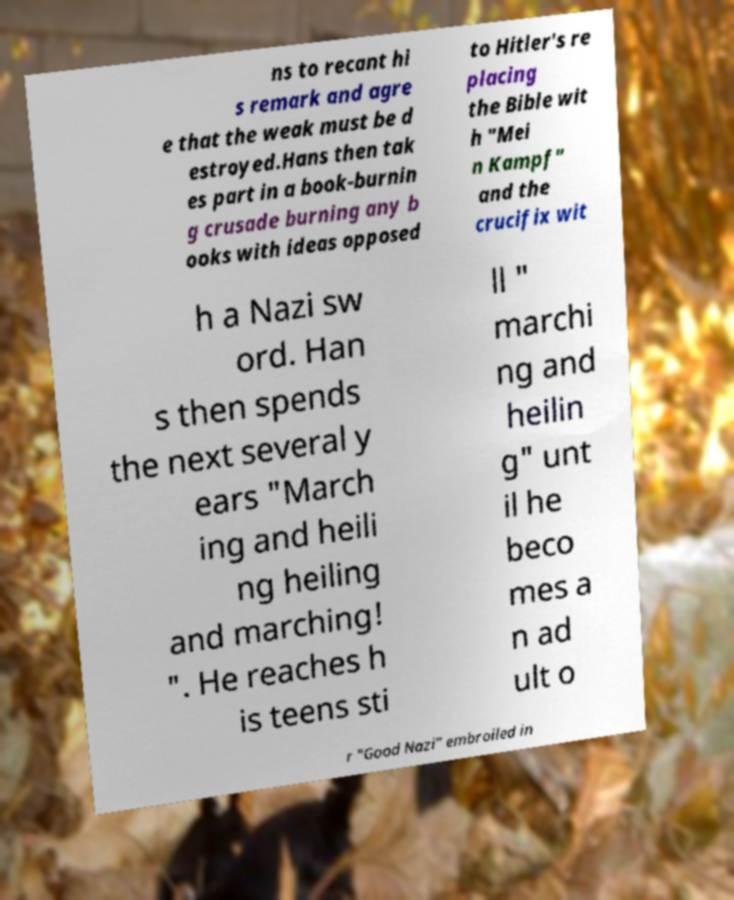I need the written content from this picture converted into text. Can you do that? ns to recant hi s remark and agre e that the weak must be d estroyed.Hans then tak es part in a book-burnin g crusade burning any b ooks with ideas opposed to Hitler's re placing the Bible wit h "Mei n Kampf" and the crucifix wit h a Nazi sw ord. Han s then spends the next several y ears "March ing and heili ng heiling and marching! ". He reaches h is teens sti ll " marchi ng and heilin g" unt il he beco mes a n ad ult o r "Good Nazi" embroiled in 